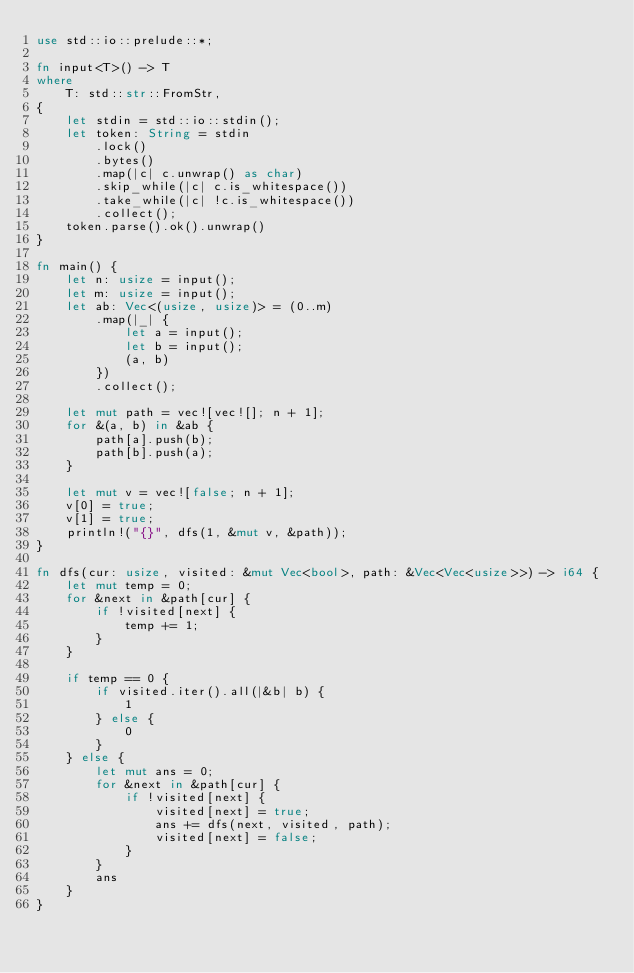Convert code to text. <code><loc_0><loc_0><loc_500><loc_500><_Rust_>use std::io::prelude::*;

fn input<T>() -> T
where
    T: std::str::FromStr,
{
    let stdin = std::io::stdin();
    let token: String = stdin
        .lock()
        .bytes()
        .map(|c| c.unwrap() as char)
        .skip_while(|c| c.is_whitespace())
        .take_while(|c| !c.is_whitespace())
        .collect();
    token.parse().ok().unwrap()
}

fn main() {
    let n: usize = input();
    let m: usize = input();
    let ab: Vec<(usize, usize)> = (0..m)
        .map(|_| {
            let a = input();
            let b = input();
            (a, b)
        })
        .collect();

    let mut path = vec![vec![]; n + 1];
    for &(a, b) in &ab {
        path[a].push(b);
        path[b].push(a);
    }

    let mut v = vec![false; n + 1];
    v[0] = true;
    v[1] = true;
    println!("{}", dfs(1, &mut v, &path));
}

fn dfs(cur: usize, visited: &mut Vec<bool>, path: &Vec<Vec<usize>>) -> i64 {
    let mut temp = 0;
    for &next in &path[cur] {
        if !visited[next] {
            temp += 1;
        }
    }

    if temp == 0 {
        if visited.iter().all(|&b| b) {
            1
        } else {
            0
        }
    } else {
        let mut ans = 0;
        for &next in &path[cur] {
            if !visited[next] {
                visited[next] = true;
                ans += dfs(next, visited, path);
                visited[next] = false;
            }
        }
        ans
    }
}
</code> 